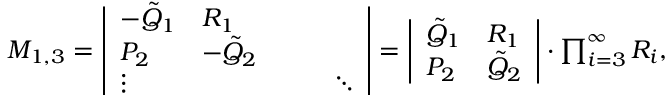<formula> <loc_0><loc_0><loc_500><loc_500>\begin{array} { r } { M _ { 1 , 3 } = \left | \begin{array} { l l l l l } { - \tilde { Q } _ { 1 } } & { R _ { 1 } } \\ { P _ { 2 } } & { - \tilde { Q } _ { 2 } } \\ { \vdots } & { \ddots } \end{array} \right | = \left | \begin{array} { l l } { \tilde { Q } _ { 1 } } & { R _ { 1 } } \\ { P _ { 2 } } & { \tilde { Q } _ { 2 } } \end{array} \right | \cdot \prod _ { i = 3 } ^ { \infty } R _ { i } , } \end{array}</formula> 